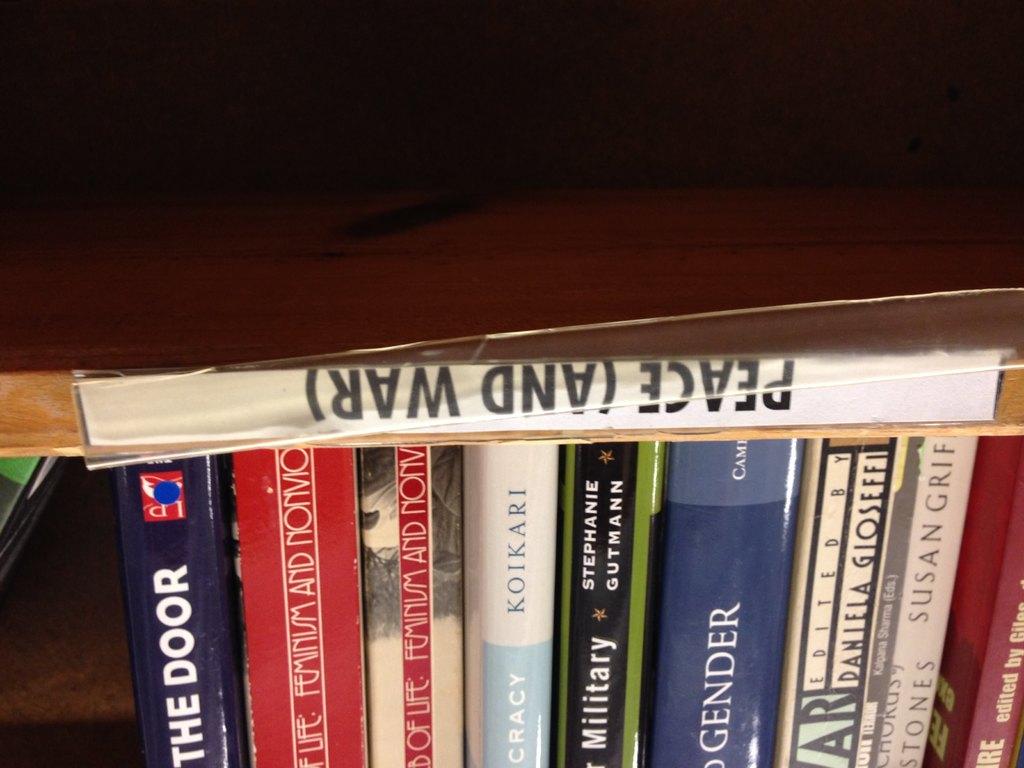What is the name of the book that is upside down?
Offer a terse response. Peace (and war). Who is the author of the light blue and white book?
Offer a terse response. Koikari. 